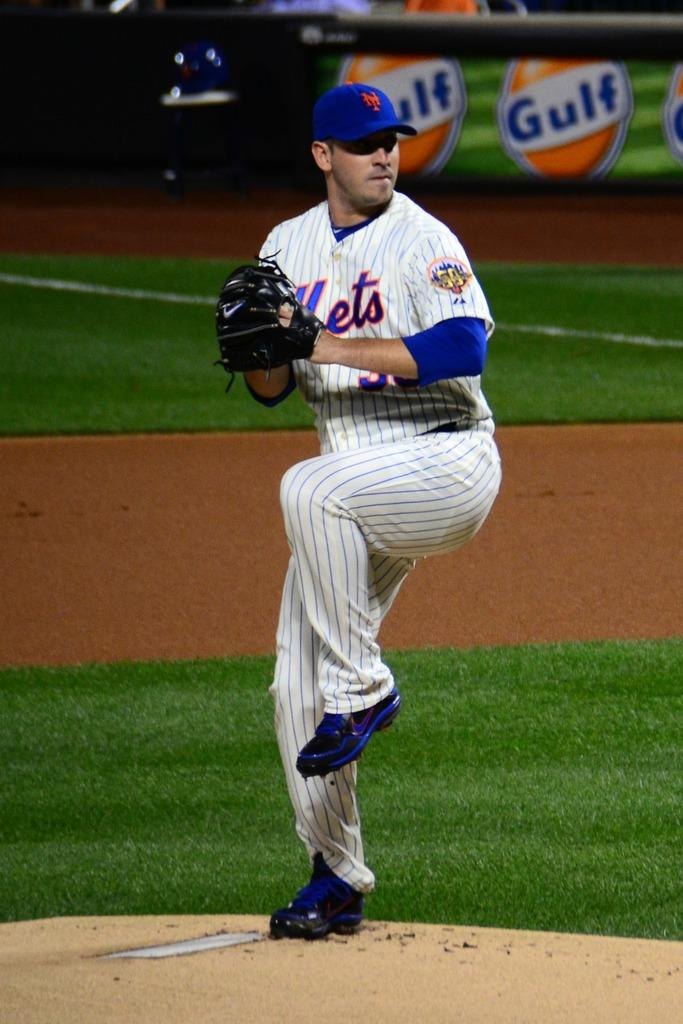What is the main subject of the image? There is a player standing in the center of the image. What is the player's position in relation to the ground? The player is standing on the ground. What type of vegetation can be seen in the background of the image? There is grass visible in the background of the image. What else can be seen in the background of the image? There is an advertisement in the background of the image. What type of dress is the player wearing in the image? There is no dress mentioned or visible in the image; the player is likely wearing sports attire. How many minutes does the player spend in the image? The duration of time the player spends in the image cannot be determined from the image itself. 